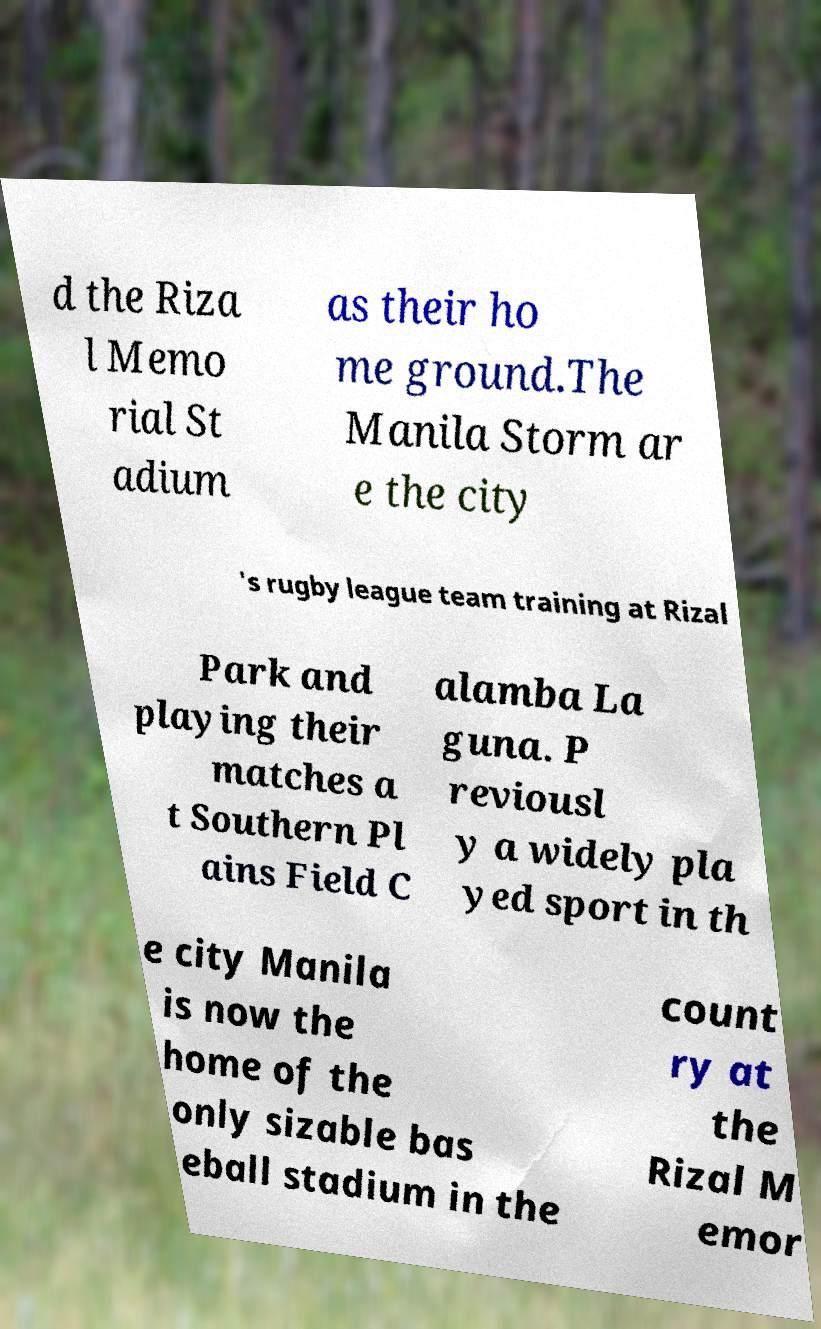Could you extract and type out the text from this image? d the Riza l Memo rial St adium as their ho me ground.The Manila Storm ar e the city 's rugby league team training at Rizal Park and playing their matches a t Southern Pl ains Field C alamba La guna. P reviousl y a widely pla yed sport in th e city Manila is now the home of the only sizable bas eball stadium in the count ry at the Rizal M emor 